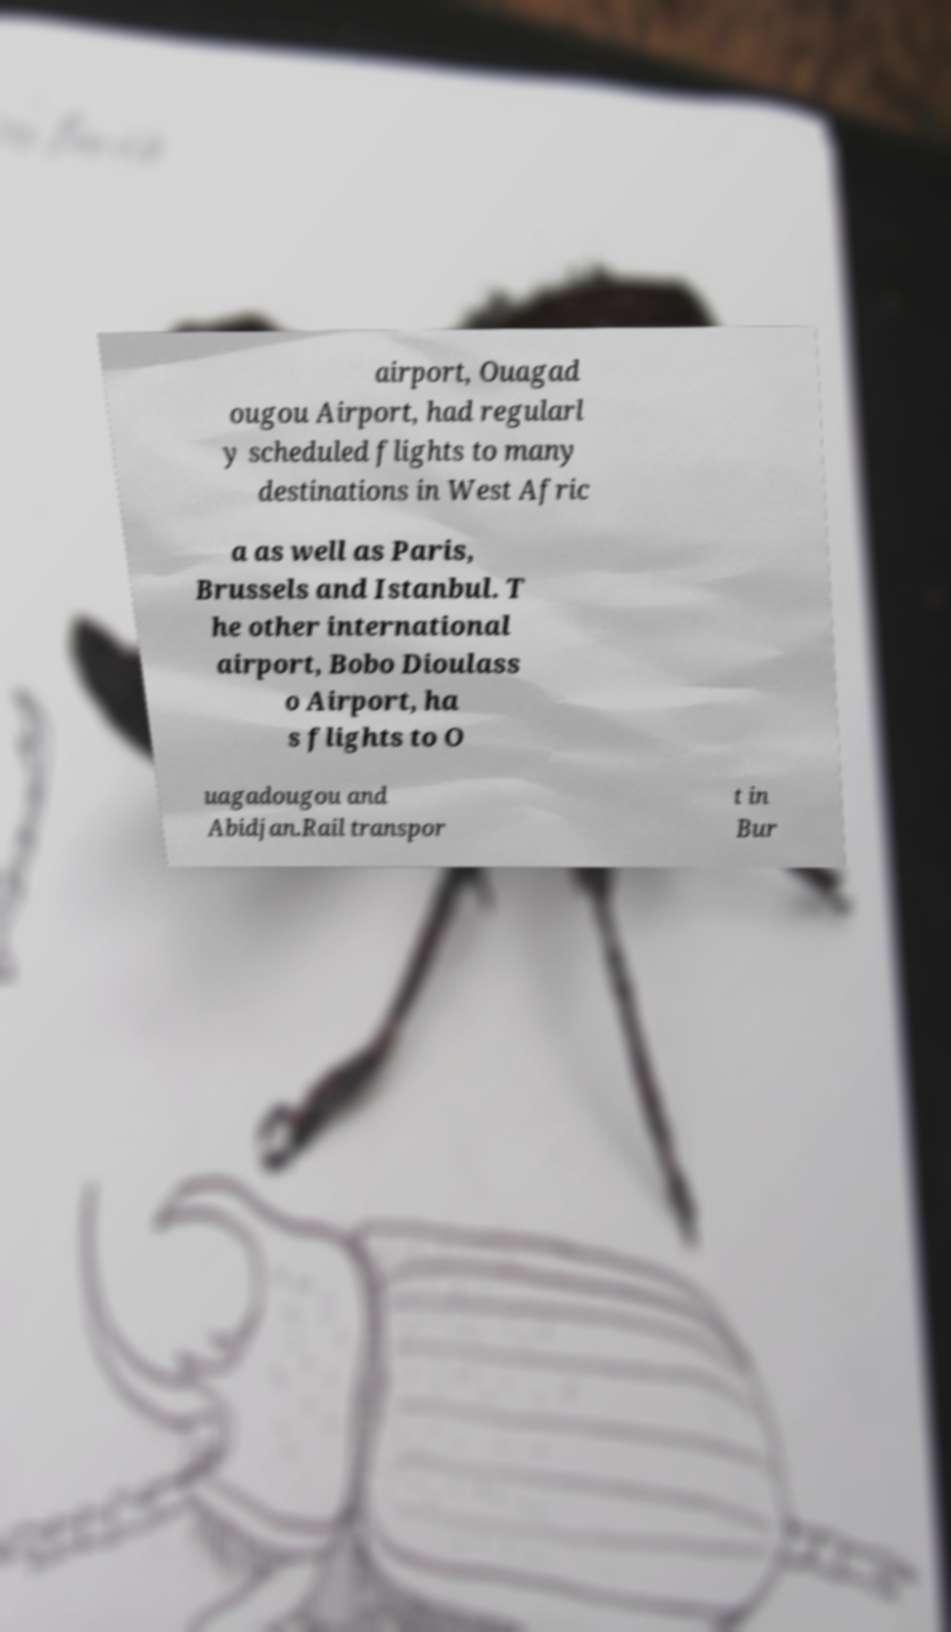I need the written content from this picture converted into text. Can you do that? airport, Ouagad ougou Airport, had regularl y scheduled flights to many destinations in West Afric a as well as Paris, Brussels and Istanbul. T he other international airport, Bobo Dioulass o Airport, ha s flights to O uagadougou and Abidjan.Rail transpor t in Bur 